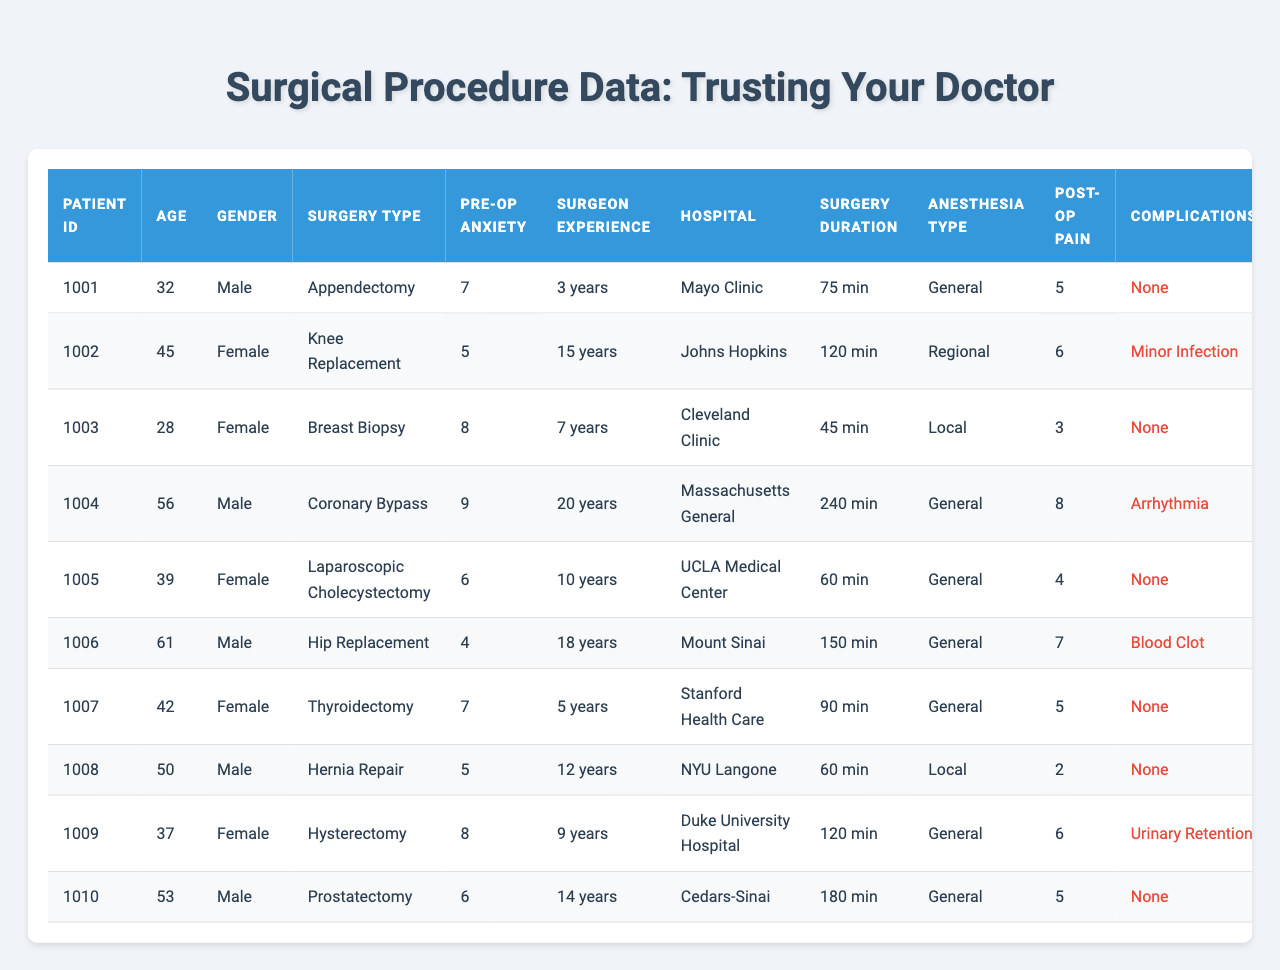What is the pre-operative anxiety level for patient ID 1003? The table lists a pre-operative anxiety level of 8 for patient ID 1003.
Answer: 8 What type of surgery did the patient with ID 1006 undergo? According to the table, patient ID 1006 underwent a Hip Replacement surgery.
Answer: Hip Replacement Which surgery type had the highest post-operative pain level? By examining the post-operative pain levels, Coronary Bypass had the highest pain level at 8.
Answer: Coronary Bypass How many days did patient ID 1004 stay in the hospital? The length of stay for patient ID 1004 is listed as 7 days in the table.
Answer: 7 days Which patient had the lowest patient satisfaction score? The patient with the lowest satisfaction score is patient ID 1004, with a score of 7.
Answer: 7 What is the average pre-operative anxiety level across all patients? The total anxiety levels are summed up (7 + 5 + 8 + 9 + 6 + 4 + 7 + 5 + 8 + 6) = 65; there are 10 patients, so the average is 65/10 = 6.5.
Answer: 6.5 Did any patient experience complications after surgery? Yes, patient ID 1002 had a minor infection and patient ID 1004 suffered from arrhythmia, indicating complications.
Answer: Yes What is the recovery time in weeks for patient ID 1008? The recovery time for patient ID 1008 is noted as 2 weeks in the table.
Answer: 2 weeks Which type of anesthesia was used for the Knee Replacement surgery? The anesthesia type used for the Knee Replacement surgery was Regional.
Answer: Regional Which patient had the surgery with the longest duration? Patient ID 1004 had the longest surgery duration of 240 minutes for a Coronary Bypass.
Answer: 240 minutes How many patients required a follow-up after their surgery? In the table, 5 patients (IDs 1002, 1004, 1006, 1009, and 1010) required follow-up after surgery.
Answer: 5 patients Is there a correlation between pre-operative anxiety level and the length of stay? A complex analysis is required; patients with higher anxiety levels tend to stay longer, but further statistical testing is needed to confirm correlation. In the table, it appears mixed, needing in-depth analysis.
Answer: Potential correlation, needs analysis What is the median length of stay for all patients? The lengths of stay are (2, 4, 1, 7, 2, 5, 3, 1, 3, 4). When sorted, they are (1, 1, 2, 2, 3, 3, 4, 4, 5, 7); with an even number of values, the median is the average of the two middle numbers (3 and 3) = 3.
Answer: 3 days Which patient had the highest surgeon experience? Patient ID 1004 had the highest surgeon experience with 20 years.
Answer: 20 years How does pre-operative anxiety level relate to post-operative pain levels based on the table? Examining the data, those with higher anxiety levels, such as patients 1003 and 1004, often reported higher post-operative pain levels; however, individual variations exist. This suggests a potential relationship.
Answer: Suggestive relationship 